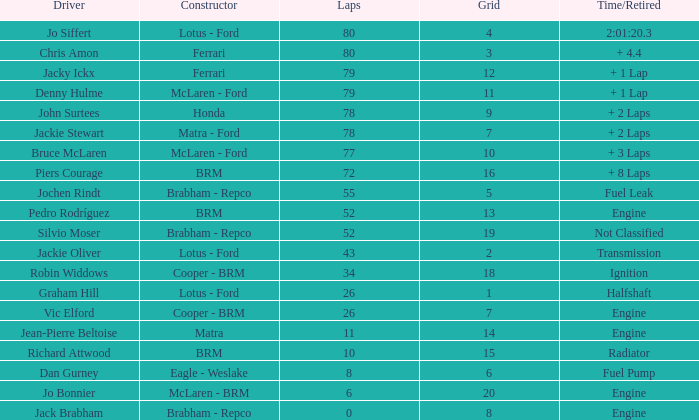When the driver richard attwood has a constructor of brm, what is the number of laps? 10.0. 